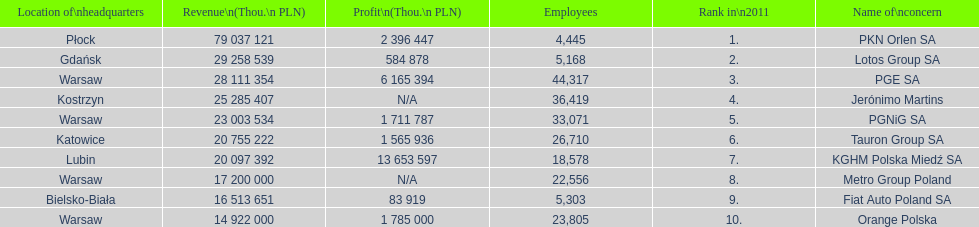What companies are listed? PKN Orlen SA, Lotos Group SA, PGE SA, Jerónimo Martins, PGNiG SA, Tauron Group SA, KGHM Polska Miedź SA, Metro Group Poland, Fiat Auto Poland SA, Orange Polska. What are the company's revenues? 79 037 121, 29 258 539, 28 111 354, 25 285 407, 23 003 534, 20 755 222, 20 097 392, 17 200 000, 16 513 651, 14 922 000. Which company has the greatest revenue? PKN Orlen SA. 